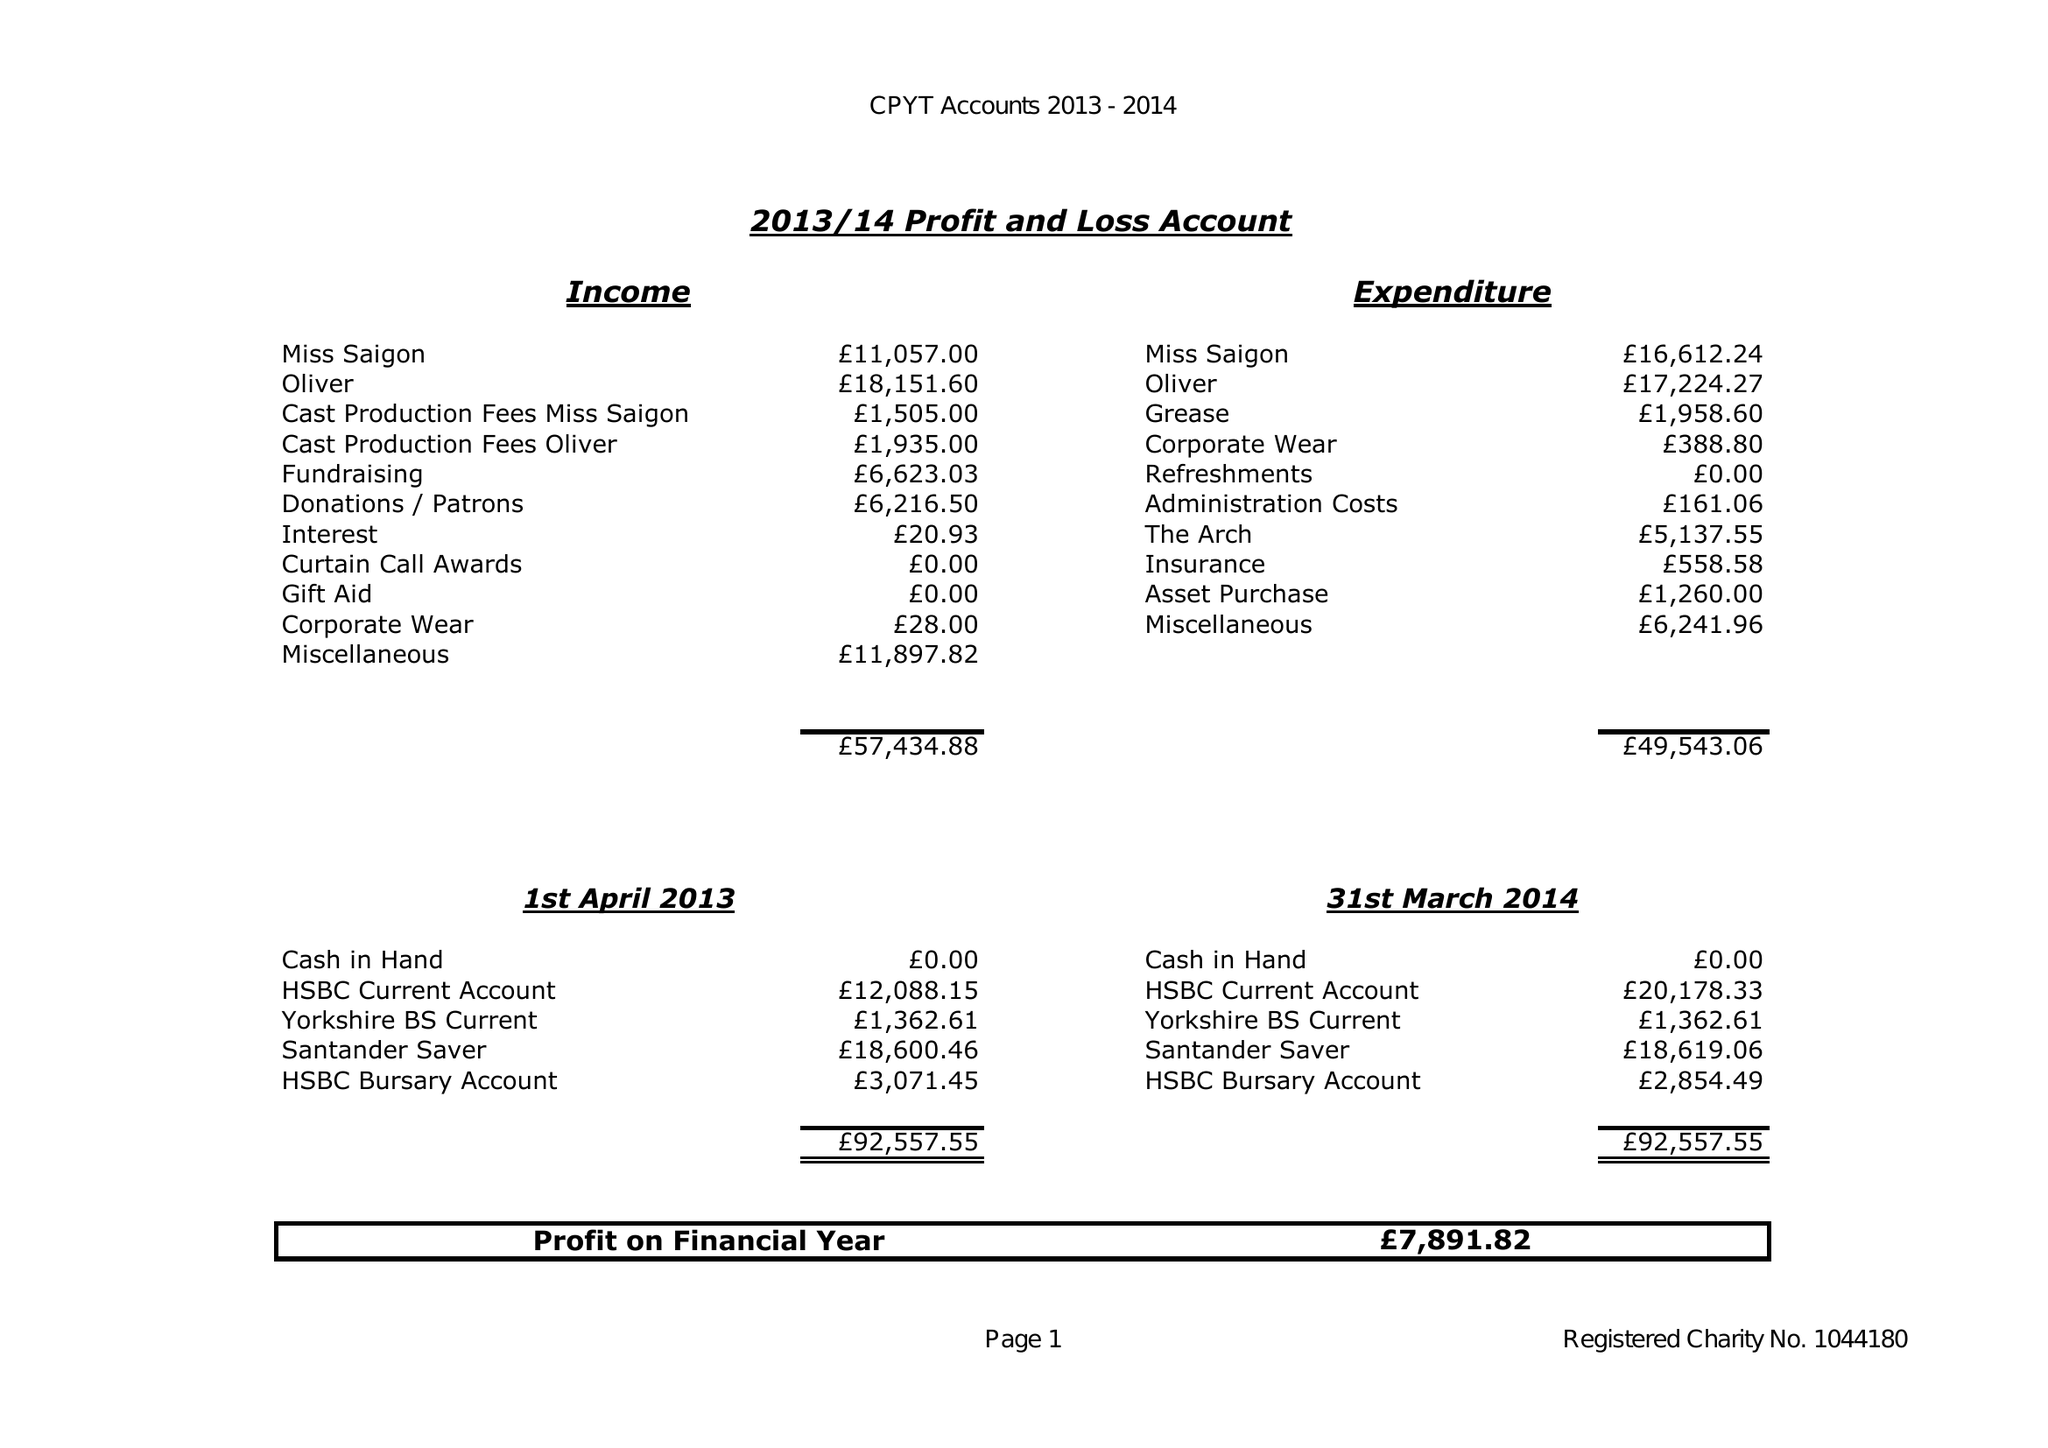What is the value for the spending_annually_in_british_pounds?
Answer the question using a single word or phrase. 49543.06 